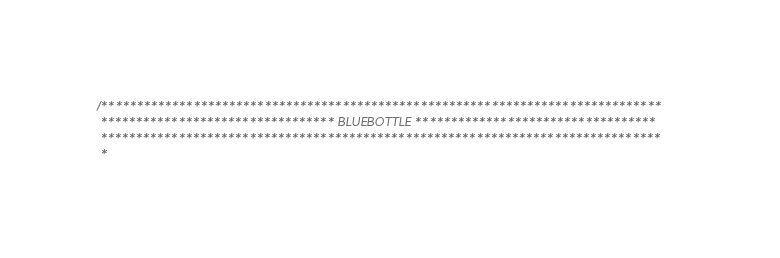<code> <loc_0><loc_0><loc_500><loc_500><_Cuda_>/*******************************************************************************
 ********************************* BLUEBOTTLE **********************************
 *******************************************************************************
 *</code> 